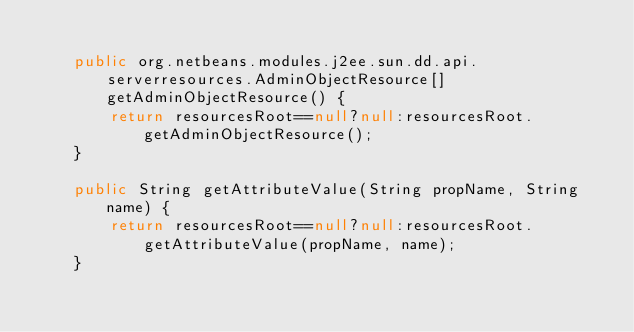<code> <loc_0><loc_0><loc_500><loc_500><_Java_>
    public org.netbeans.modules.j2ee.sun.dd.api.serverresources.AdminObjectResource[] getAdminObjectResource() {
        return resourcesRoot==null?null:resourcesRoot.getAdminObjectResource();
    }

    public String getAttributeValue(String propName, String name) {
        return resourcesRoot==null?null:resourcesRoot.getAttributeValue(propName, name);
    }
</code> 